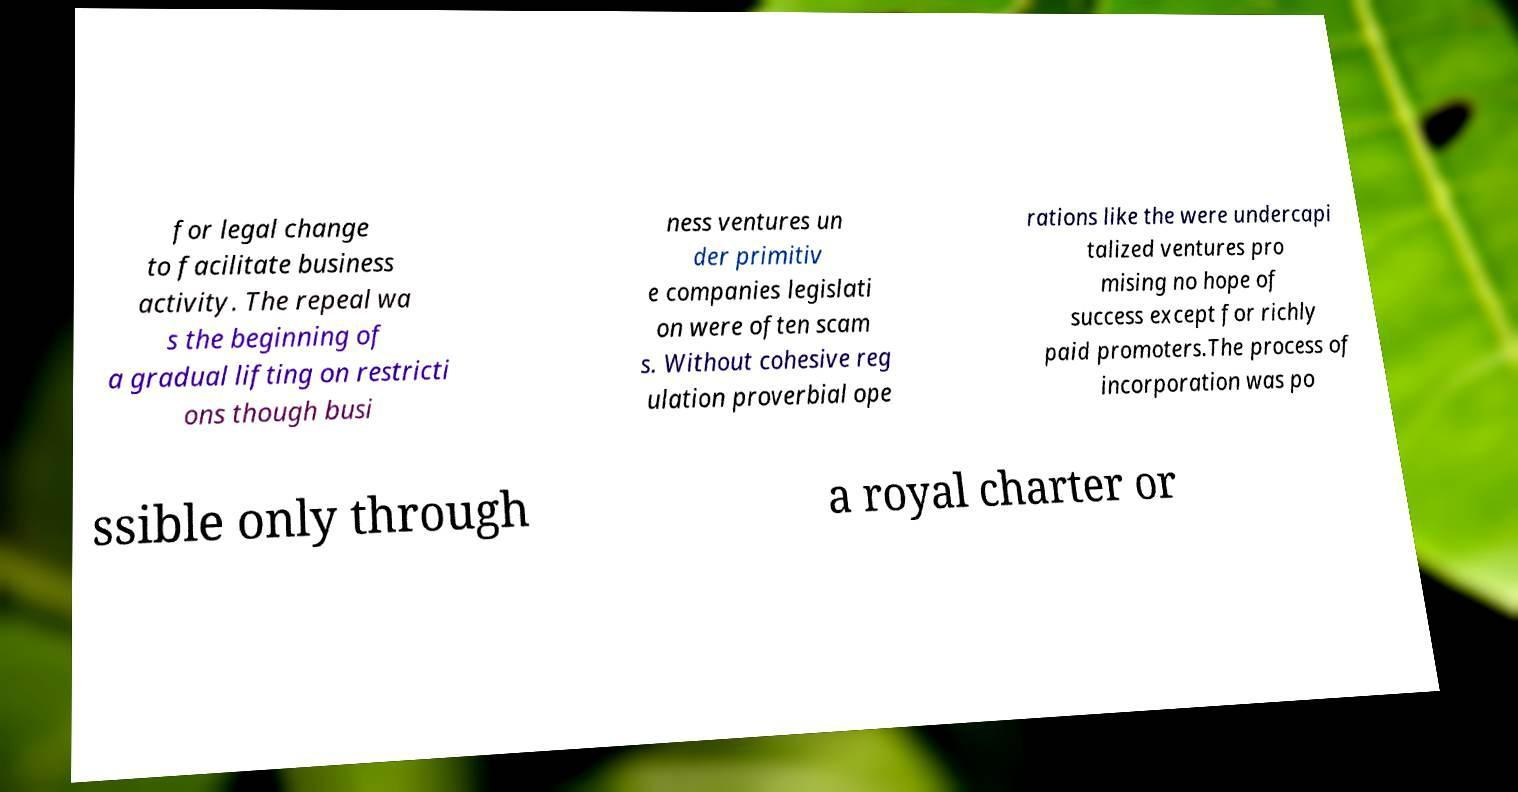For documentation purposes, I need the text within this image transcribed. Could you provide that? for legal change to facilitate business activity. The repeal wa s the beginning of a gradual lifting on restricti ons though busi ness ventures un der primitiv e companies legislati on were often scam s. Without cohesive reg ulation proverbial ope rations like the were undercapi talized ventures pro mising no hope of success except for richly paid promoters.The process of incorporation was po ssible only through a royal charter or 